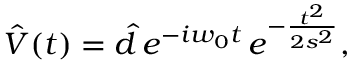<formula> <loc_0><loc_0><loc_500><loc_500>\hat { V } ( t ) = \hat { d } \, e ^ { - i w _ { 0 } t } \, e ^ { - \frac { t ^ { 2 } } { 2 s ^ { 2 } } } ,</formula> 